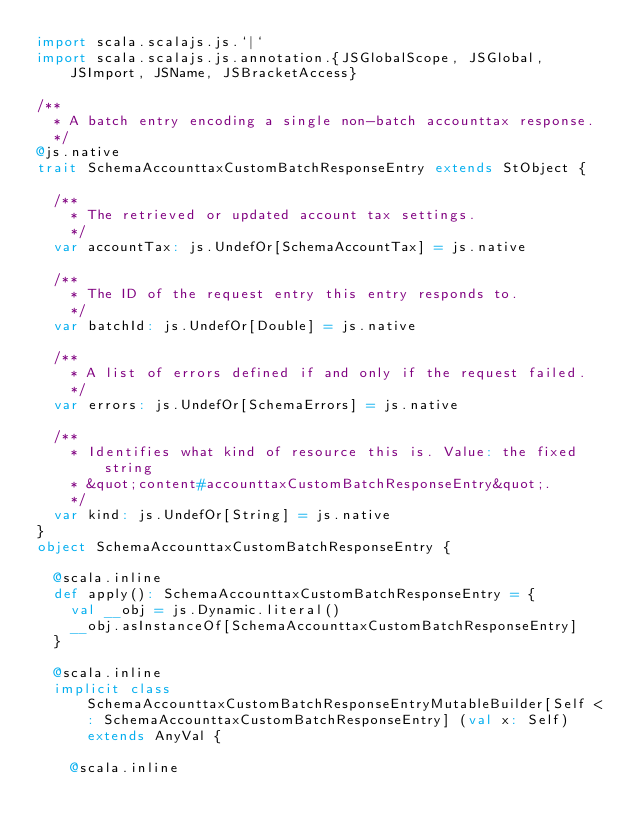Convert code to text. <code><loc_0><loc_0><loc_500><loc_500><_Scala_>import scala.scalajs.js.`|`
import scala.scalajs.js.annotation.{JSGlobalScope, JSGlobal, JSImport, JSName, JSBracketAccess}

/**
  * A batch entry encoding a single non-batch accounttax response.
  */
@js.native
trait SchemaAccounttaxCustomBatchResponseEntry extends StObject {
  
  /**
    * The retrieved or updated account tax settings.
    */
  var accountTax: js.UndefOr[SchemaAccountTax] = js.native
  
  /**
    * The ID of the request entry this entry responds to.
    */
  var batchId: js.UndefOr[Double] = js.native
  
  /**
    * A list of errors defined if and only if the request failed.
    */
  var errors: js.UndefOr[SchemaErrors] = js.native
  
  /**
    * Identifies what kind of resource this is. Value: the fixed string
    * &quot;content#accounttaxCustomBatchResponseEntry&quot;.
    */
  var kind: js.UndefOr[String] = js.native
}
object SchemaAccounttaxCustomBatchResponseEntry {
  
  @scala.inline
  def apply(): SchemaAccounttaxCustomBatchResponseEntry = {
    val __obj = js.Dynamic.literal()
    __obj.asInstanceOf[SchemaAccounttaxCustomBatchResponseEntry]
  }
  
  @scala.inline
  implicit class SchemaAccounttaxCustomBatchResponseEntryMutableBuilder[Self <: SchemaAccounttaxCustomBatchResponseEntry] (val x: Self) extends AnyVal {
    
    @scala.inline</code> 